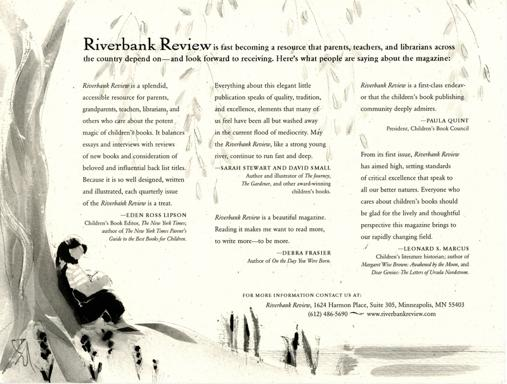What emotions might a child feel when looking at this image, and how can literature help process those feelings? The image conveys a sense of calmness and contemplation, which may make a child feel peaceful or pensive. Children's literature often addresses such emotions by offering stories that validate and explore inner feelings. Books provide a safe space to see these emotions mirrored in characters and to learn that one's inner world is as important as the outer. They teach children that it's okay to take a break from the outer world and reflect, just as the figure in the image is doing. 